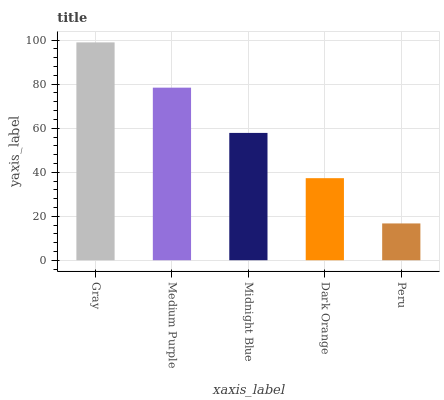Is Peru the minimum?
Answer yes or no. Yes. Is Gray the maximum?
Answer yes or no. Yes. Is Medium Purple the minimum?
Answer yes or no. No. Is Medium Purple the maximum?
Answer yes or no. No. Is Gray greater than Medium Purple?
Answer yes or no. Yes. Is Medium Purple less than Gray?
Answer yes or no. Yes. Is Medium Purple greater than Gray?
Answer yes or no. No. Is Gray less than Medium Purple?
Answer yes or no. No. Is Midnight Blue the high median?
Answer yes or no. Yes. Is Midnight Blue the low median?
Answer yes or no. Yes. Is Gray the high median?
Answer yes or no. No. Is Peru the low median?
Answer yes or no. No. 